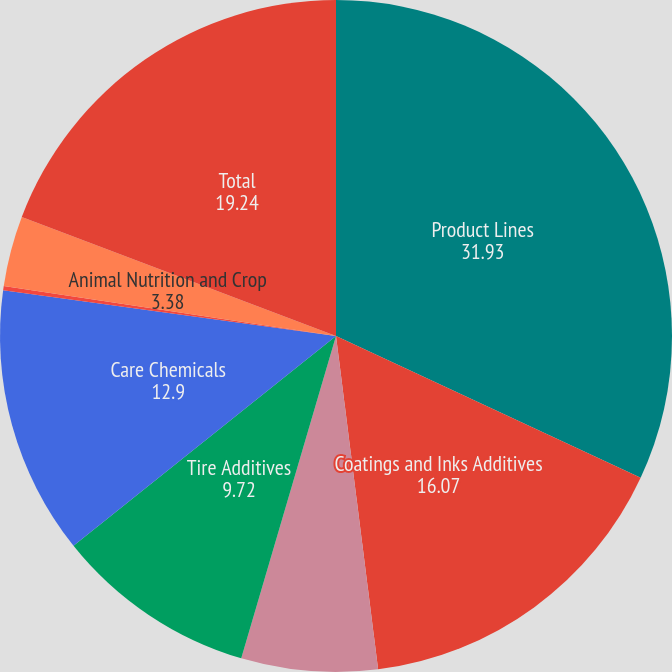Convert chart to OTSL. <chart><loc_0><loc_0><loc_500><loc_500><pie_chart><fcel>Product Lines<fcel>Coatings and Inks Additives<fcel>Adhesives Resins<fcel>Tire Additives<fcel>Care Chemicals<fcel>Specialty Fluids<fcel>Animal Nutrition and Crop<fcel>Total<nl><fcel>31.93%<fcel>16.07%<fcel>6.55%<fcel>9.72%<fcel>12.9%<fcel>0.21%<fcel>3.38%<fcel>19.24%<nl></chart> 